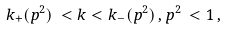Convert formula to latex. <formula><loc_0><loc_0><loc_500><loc_500>k _ { + } ( p ^ { 2 } ) \, < k < k _ { - } ( p ^ { 2 } ) \, , p ^ { 2 } \, < 1 \, ,</formula> 